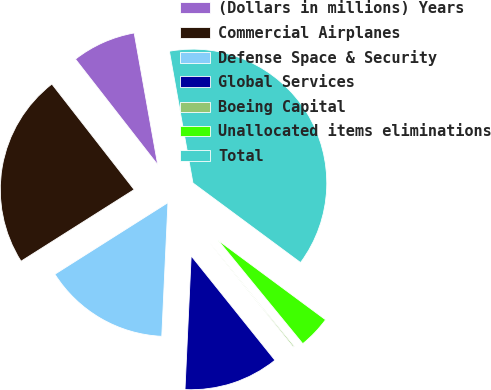Convert chart. <chart><loc_0><loc_0><loc_500><loc_500><pie_chart><fcel>(Dollars in millions) Years<fcel>Commercial Airplanes<fcel>Defense Space & Security<fcel>Global Services<fcel>Boeing Capital<fcel>Unallocated items eliminations<fcel>Total<nl><fcel>7.72%<fcel>23.45%<fcel>15.28%<fcel>11.5%<fcel>0.16%<fcel>3.94%<fcel>37.95%<nl></chart> 